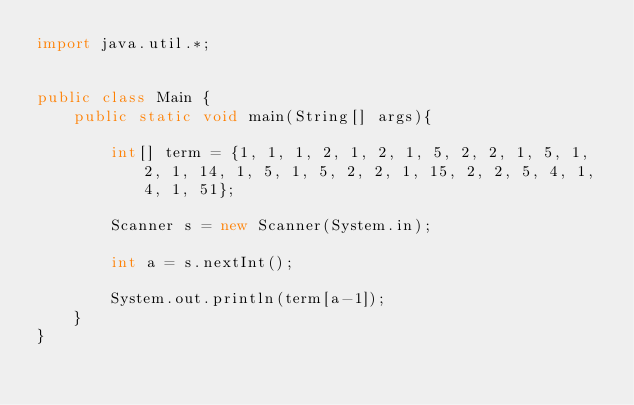Convert code to text. <code><loc_0><loc_0><loc_500><loc_500><_Java_>import java.util.*;


public class Main {
    public static void main(String[] args){

        int[] term = {1, 1, 1, 2, 1, 2, 1, 5, 2, 2, 1, 5, 1, 2, 1, 14, 1, 5, 1, 5, 2, 2, 1, 15, 2, 2, 5, 4, 1, 4, 1, 51};

        Scanner s = new Scanner(System.in);
        
        int a = s.nextInt();

        System.out.println(term[a-1]);
    }
}</code> 